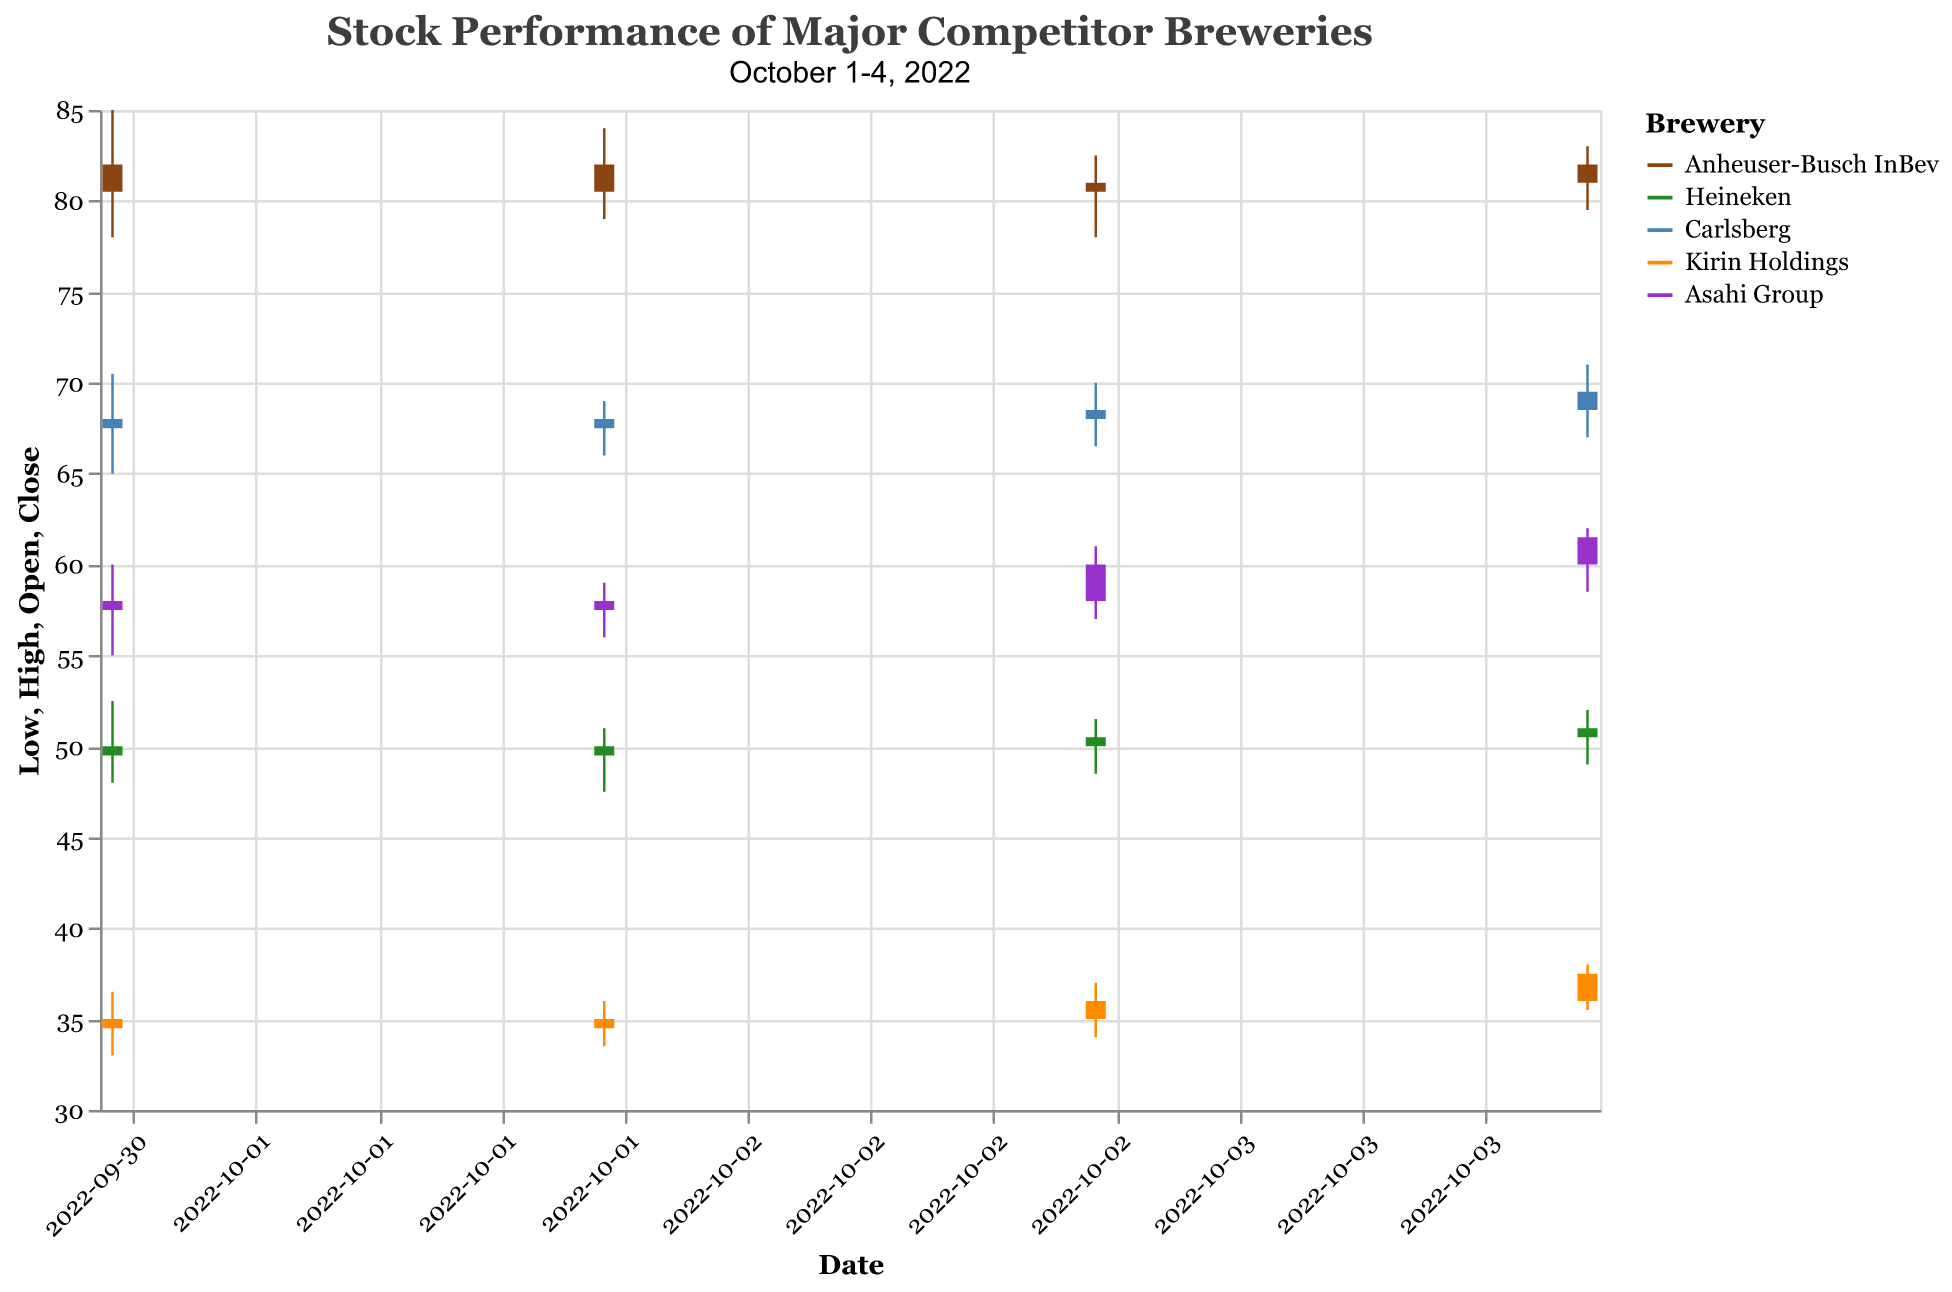what is the stock price range of Anheuser-Busch InBev on October 1, 2022? Determine the highest and lowest points in the candlestick for Anheuser-Busch InBev on October 1, 2022. The high is 85.0 and the low is 78.0. This makes the range 85.0 - 78.0 = 7.0
Answer: 7.0 How did Heineken's stock price change from October 1 to October 4, 2022? Refer to the opening price on October 1, 2022 (50.0) and the closing price on October 4, 2022 (51.0). The change is 51.0 - 50.0 = 1.0.
Answer: 1.0 Which company had the highest trading volume on October 3, 2022? Review the volume data for each company on October 3, 2022. Carlsberg had the highest trading volume at 880,000.
Answer: Carlsberg Was Kirin Holdings' stock price increasing or decreasing over the period? Observe the opening price on October 1, 2022 (35.0) and the closing price on October 4, 2022 (37.5). Since the closing price is higher, Kirin Holdings' stock price was increasing.
Answer: Increasing Compare the stock price volatility of Carlsberg and Asahi Group on October 4, 2022. Calculate the range of high and low prices for each company on October 4, 2022. Carlsberg (71.0 - 67.0 = 4.0), Asahi Group (62.0 - 58.5 = 3.5). Carlsberg's stock price volatility was higher.
Answer: Carlsberg What was the opening price of Asahi Group on October 3, 2022? Check the opening price of Asahi Group on October 3, 2022, which is 58.0.
Answer: 58.0 Which company showed the highest closing price on October 1, 2022? Look at the closing prices for all companies on October 1, 2022. Anheuser-Busch InBev has the highest closing price of 82.0.
Answer: Anheuser-Busch InBev On what date did Heineken's stock price close higher than it opened? Look at the opening and closing prices of Heineken. It closed higher than it opened on October 2, October 3, and October 4, 2022.
Answer: October 2, October 3, October 4, 2022 How many days did Kirin Holdings have a higher closing price than opening price? Compare the closing and opening prices for each day:
- October 1: Close < Open
- October 2: Close > Open
- October 3: Close > Open
- October 4: Close > Open
Kirin Holdings had a higher closing price than the opening price on three days.
Answer: Three days What is the average closing price of Carlsberg over the given days? Find the closing prices for Carlsberg over the days: 67.5, 68.0, 68.5, 69.5. Then calculate the average: (67.5 + 68.0 + 68.5 + 69.5)/4 = 68.375.
Answer: 68.375 